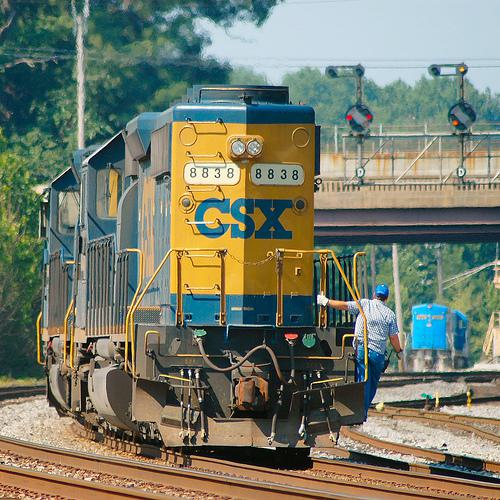How many trains would there be in the image if one additional train was added in the scene? Currently, there are two trains visible in the image. If one more train were to be added to the scene, there would be a total of three trains. 